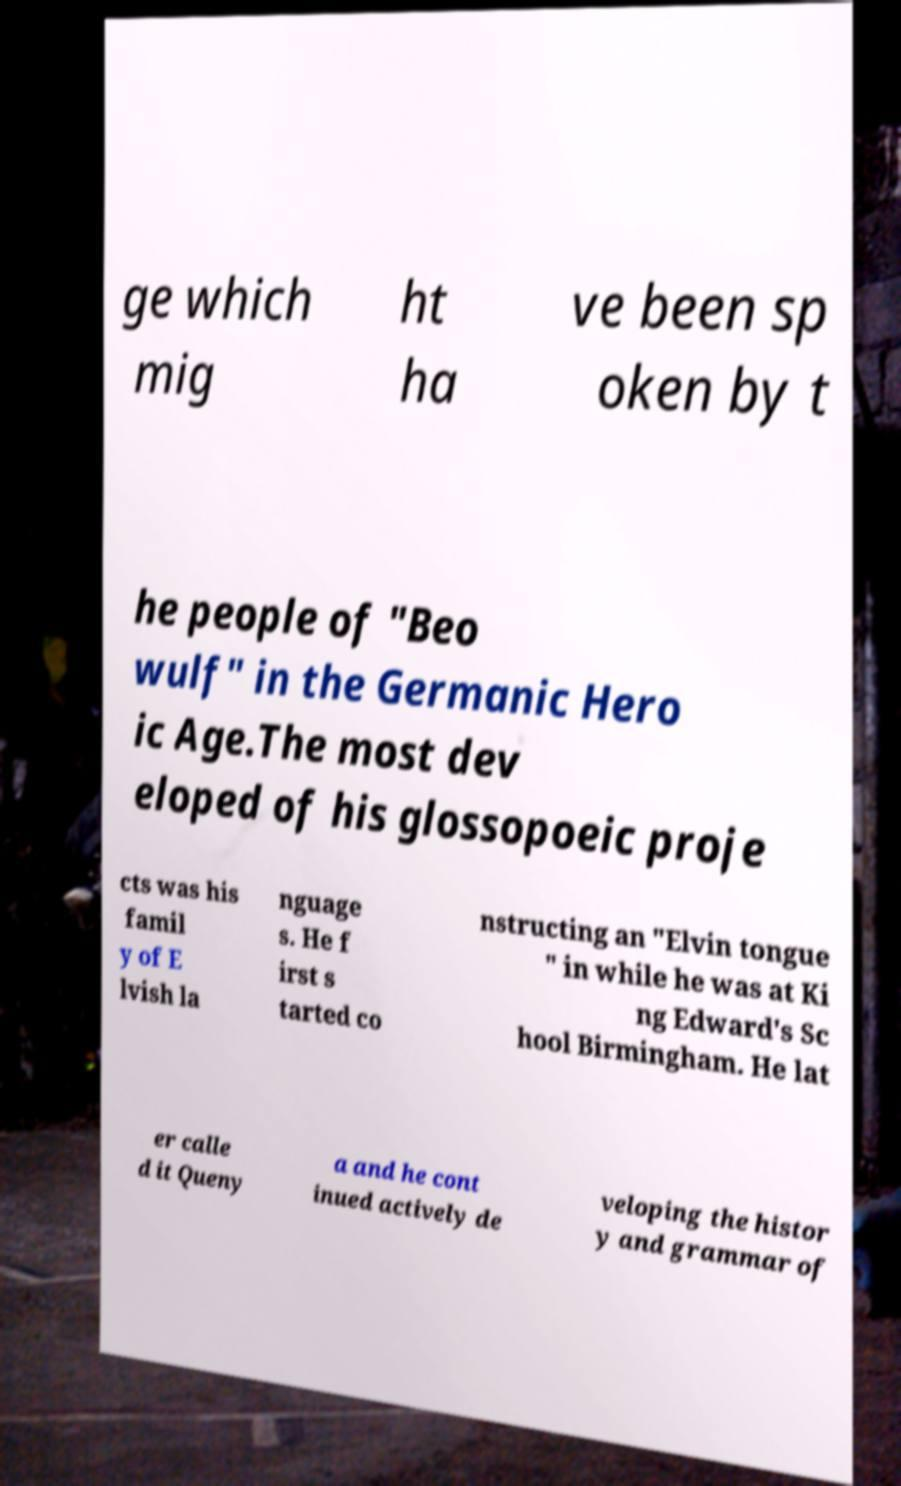Can you read and provide the text displayed in the image?This photo seems to have some interesting text. Can you extract and type it out for me? ge which mig ht ha ve been sp oken by t he people of "Beo wulf" in the Germanic Hero ic Age.The most dev eloped of his glossopoeic proje cts was his famil y of E lvish la nguage s. He f irst s tarted co nstructing an "Elvin tongue " in while he was at Ki ng Edward's Sc hool Birmingham. He lat er calle d it Queny a and he cont inued actively de veloping the histor y and grammar of 